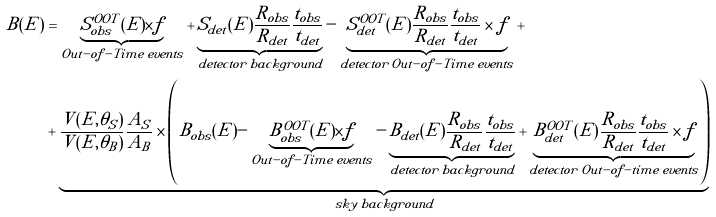<formula> <loc_0><loc_0><loc_500><loc_500>B ( E ) & = \underbrace { S ^ { O O T } _ { o b s } ( E ) \times f } _ { O u t - o f - T i m e \, e v e n t s } + \underbrace { S _ { d e t } ( E ) \frac { R _ { o b s } } { R _ { d e t } } \frac { t _ { o b s } } { t _ { d e t } } } _ { d e t e c t o r \, b a c k g r o u n d } - \underbrace { S ^ { O O T } _ { d e t } ( E ) \frac { R _ { o b s } } { R _ { d e t } } \frac { t _ { o b s } } { t _ { d e t } } \times f } _ { d e t e c t o r \, O u t - o f - T i m e \, e v e n t s } + \\ & + \underbrace { \frac { V ( E , \theta _ { S } ) } { V ( E , \theta _ { B } ) } \frac { A _ { S } } { A _ { B } } \times \left ( B _ { o b s } ( E ) - \underbrace { B ^ { O O T } _ { o b s } ( E ) \times f } _ { O u t - o f - T i m e \, e v e n t s } - \underbrace { B _ { d e t } ( E ) \frac { R _ { o b s } } { R _ { d e t } } \frac { t _ { o b s } } { t _ { d e t } } } _ { d e t e c t o r \, b a c k g r o u n d } + \underbrace { B ^ { O O T } _ { d e t } ( E ) \frac { R _ { o b s } } { R _ { d e t } } \frac { t _ { o b s } } { t _ { d e t } } \times f } _ { d e t e c t o r \, O u t - o f - t i m e \, e v e n t s } \right ) } _ { s k y \, b a c k g r o u n d } \\</formula> 